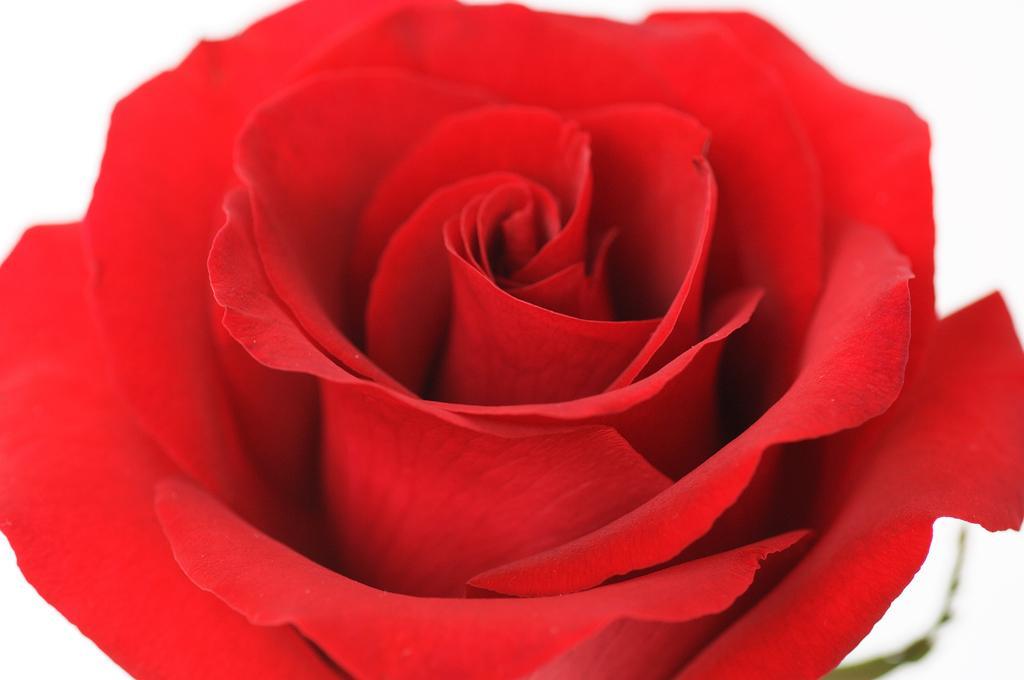Can you describe this image briefly? In this picture there is a red color rose in the image. 